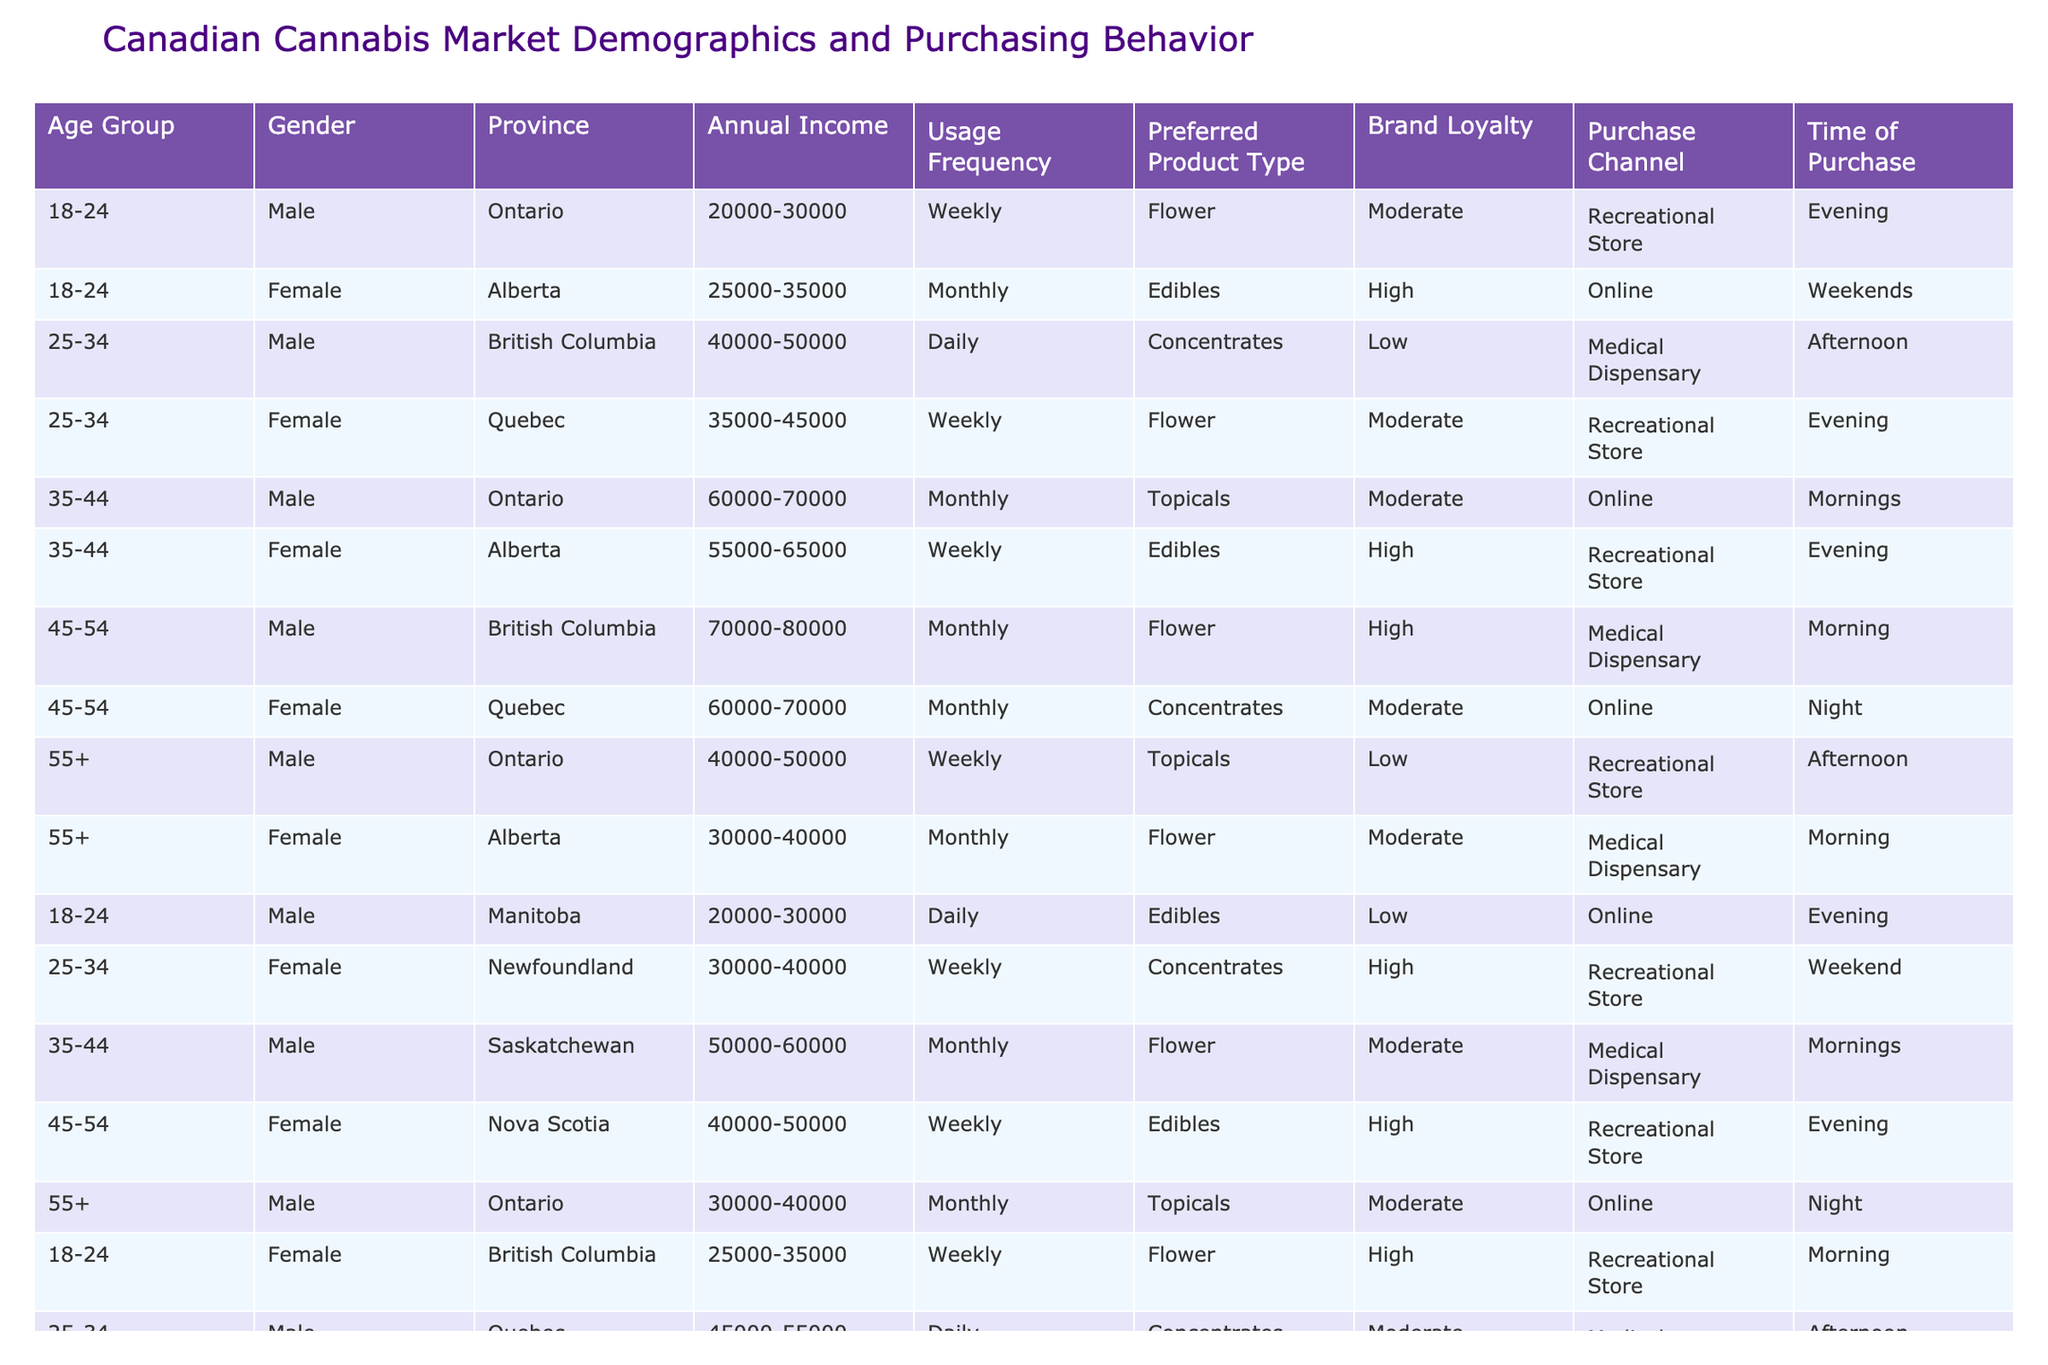What is the most common preferred product type among males aged 35-44? Based on the data, the preferred product type for males aged 35-44 is 'Topicals' (1 out of 2 entries specifies Topicals, while the other is Flower).
Answer: Topicals What percentage of females in Alberta prefer Edibles as their product type? In Alberta, there are 4 female entries, of which 2 have Edibles as the preferred product type. Thus, the percentage is (2/4) * 100 = 50%.
Answer: 50% How many males aged 55+ purchase cannabis daily? The data shows that there are a total of 3 males aged 55+, and none of them purchase cannabis daily; all purchase monthly or weekly.
Answer: 0 Which province has the highest number of respondents who prefer Flower? Counting the number of times Flower is mentioned, Ontario (3), Alberta (3), British Columbia (2), Quebec (2), and Nova Scotia (1). Thus, Ontario and Alberta tie for the highest at 3.
Answer: Ontario and Alberta Are online purchases more popular in any specific age group? By reviewing the data, online purchases are combined for different age groups. However, the trend suggests males 35-44 and 55+ have common online usage. The total data indicate that 4 out of 13 use Online across multiple age segments, showing it's a preferred channel overall rather than age-specific.
Answer: No What is the average annual income of female consumers across all age groups? The annual income for females is: 25000-35000 (averages to 30000), 35000-45000 (averages to 40000), 55000-65000 (averages to 60000), and 60000-70000 (averages to 65000). Summing them gives (30000 + 40000 + 60000 + 65000) = 195000, and the average over 4 entries is 195000/4 = 48750.
Answer: 48750 How many respondents buy cannabis weekly? From the data, the entries showing 'Weekly' usage frequency total 6 out of 20 respondents.
Answer: 6 Which brand loyalty category is most prevalent among consumers in British Columbia? An analysis of British Columbia shows that there are 4 respondents, of which 2 exhibit 'High' brand loyalty, thus making it the most prevalent loyalty category at that location.
Answer: High What age group shows the highest average income? By evaluating the different age groups: 18-24 (25000-35000 avg: 30000), 25-34 (40000-50000 avg: 45000), 35-44 (55000-65000 avg: 60000), 45-54 (70000-80000 avg: 75000), and 55+ (30000-50000 avg: 40000). Therefore, 45-54 is the highest.
Answer: 45-54 Are most consumers purchasing cannabis during evenings? Checking the time of purchase data shows that 'Evening' is selected 7 times out of 20 total respondents, hence it is the most common time for purchase.
Answer: Yes What is the total number of respondents who prefer Concentrates? Analyzing the data, Concentrates are preferred by 5 respondents across the dataset.
Answer: 5 